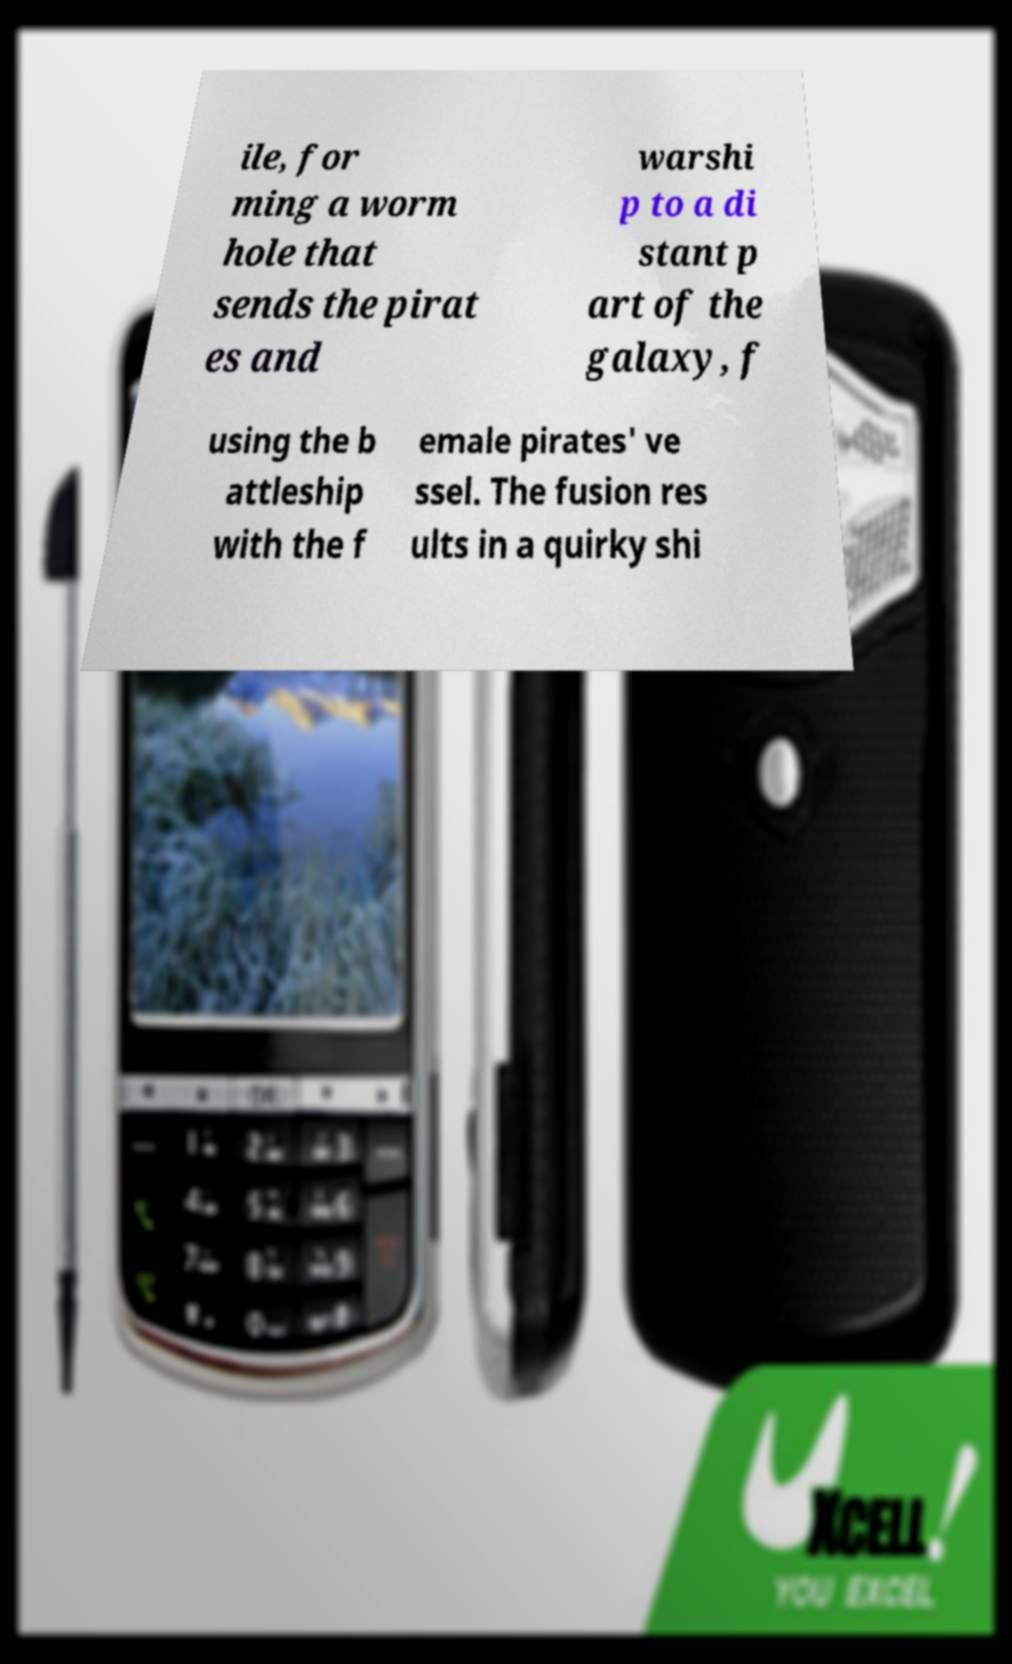Could you assist in decoding the text presented in this image and type it out clearly? ile, for ming a worm hole that sends the pirat es and warshi p to a di stant p art of the galaxy, f using the b attleship with the f emale pirates' ve ssel. The fusion res ults in a quirky shi 